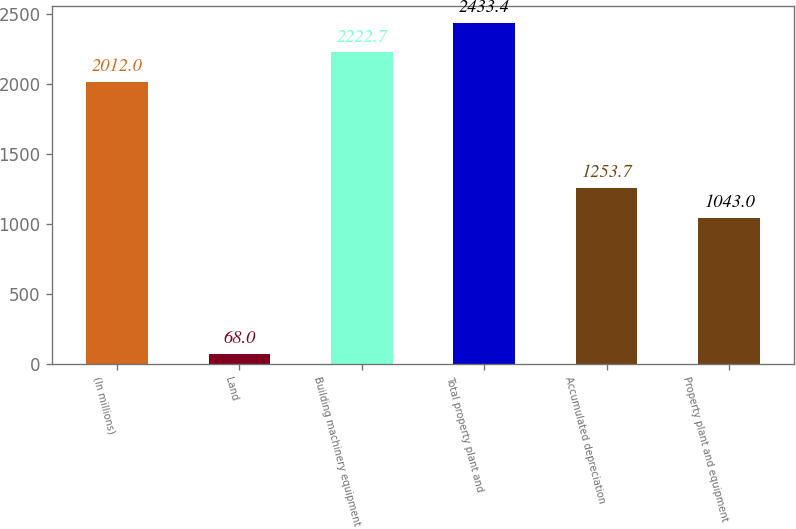Convert chart. <chart><loc_0><loc_0><loc_500><loc_500><bar_chart><fcel>(In millions)<fcel>Land<fcel>Building machinery equipment<fcel>Total property plant and<fcel>Accumulated depreciation<fcel>Property plant and equipment<nl><fcel>2012<fcel>68<fcel>2222.7<fcel>2433.4<fcel>1253.7<fcel>1043<nl></chart> 